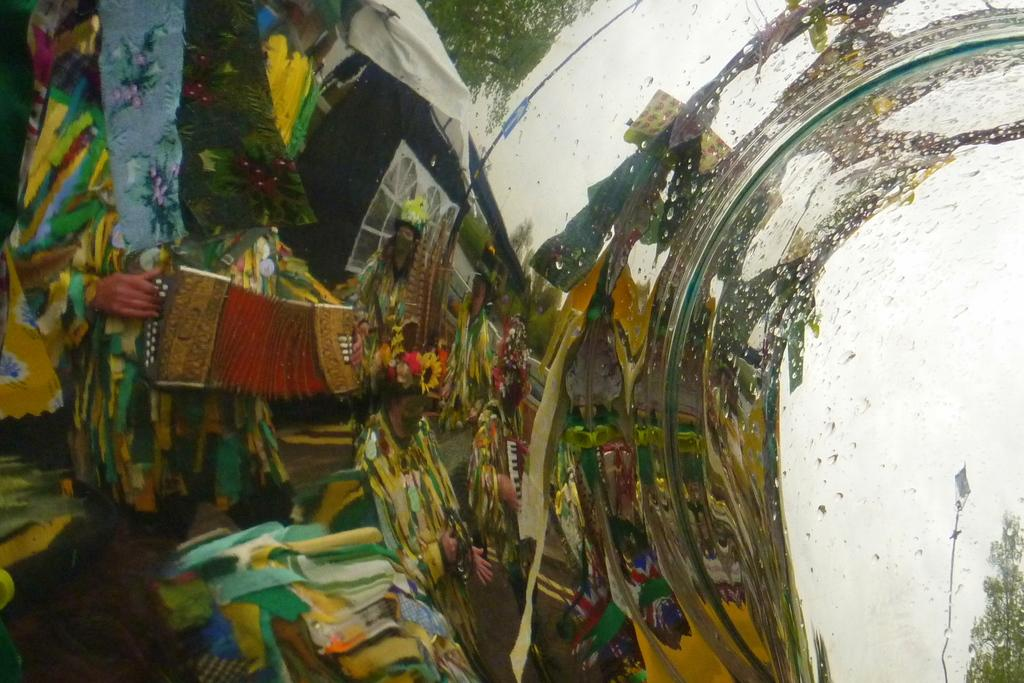What is reflected in the image? There is a reflection of a pole and a light in the image. What type of vegetation can be seen in the image? There are trees visible in the image. What are the people in the image doing? There is a group of people holding musical instruments in the image. What type of structure is present in the image? There is a building in the image. What can be seen in the sky in the image? There is a sky visible in the image. What type of powder is being used by the people in the image? There is no powder present in the image; the people are holding musical instruments. Can you see a train in the image? There is no train present in the image. 